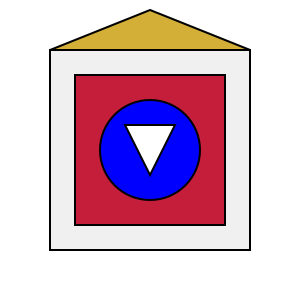Examine the coat of arms depicted above. Which heraldic symbol represents loyalty and fidelity, and in which part of the shield is it located? To answer this question, we need to analyze the coat of arms step-by-step:

1. The shield is divided into several parts, each containing different heraldic symbols.

2. The main elements of the coat of arms are:
   a) A gold (yellow) chevron at the top
   b) A red field covering most of the shield
   c) A blue circle in the center
   d) A white triangle within the blue circle

3. Each of these elements has a specific meaning in heraldry:
   a) Gold/yellow typically represents honor and loyalty
   b) Red often symbolizes military strength and magnanimity
   c) Blue is associated with truth and loyalty
   d) White/silver generally represents peace and sincerity

4. The shape of the symbols is also significant:
   a) The circle is a perfect shape with no beginning or end, often representing eternity or wholeness
   b) The triangle pointing downwards can represent the Holy Trinity or stability

5. In heraldry, the blue circle is known as a "roundel azure" and is specifically associated with loyalty and fidelity.

6. This blue roundel is located in the center of the shield, which is the most prominent and honorable position in heraldic design.

Therefore, the heraldic symbol representing loyalty and fidelity is the blue circle (roundel azure), located in the center of the shield.
Answer: The blue circle (roundel azure) in the center of the shield. 